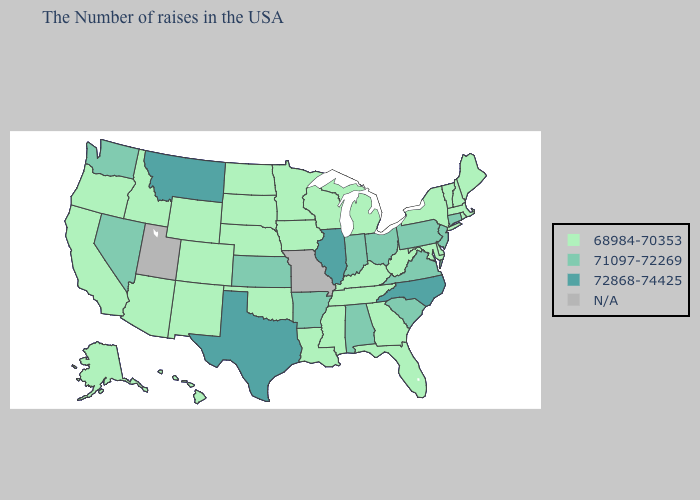Does the map have missing data?
Concise answer only. Yes. Does Texas have the highest value in the South?
Concise answer only. Yes. How many symbols are there in the legend?
Give a very brief answer. 4. What is the highest value in states that border West Virginia?
Answer briefly. 71097-72269. What is the lowest value in the USA?
Give a very brief answer. 68984-70353. What is the highest value in the West ?
Concise answer only. 72868-74425. What is the lowest value in the MidWest?
Answer briefly. 68984-70353. What is the value of Oklahoma?
Short answer required. 68984-70353. What is the value of Montana?
Concise answer only. 72868-74425. Name the states that have a value in the range N/A?
Quick response, please. Missouri, Utah. Among the states that border Ohio , which have the lowest value?
Short answer required. West Virginia, Michigan, Kentucky. 